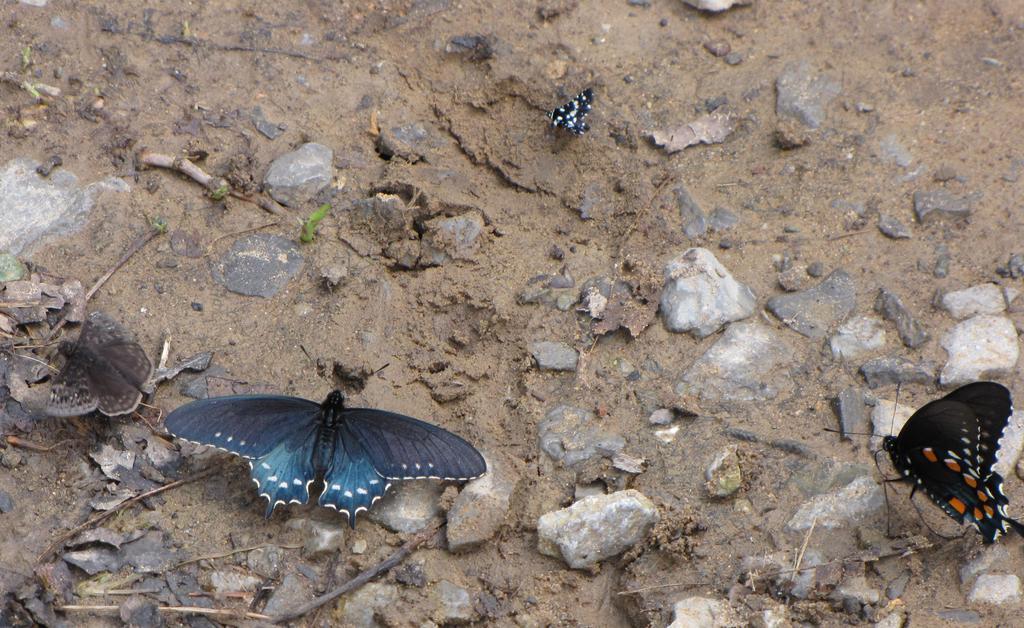How would you summarize this image in a sentence or two? In this picture there are butterflies in different colors. At the bottom there is mud and there are stones and there are dried leaves and sticks. 